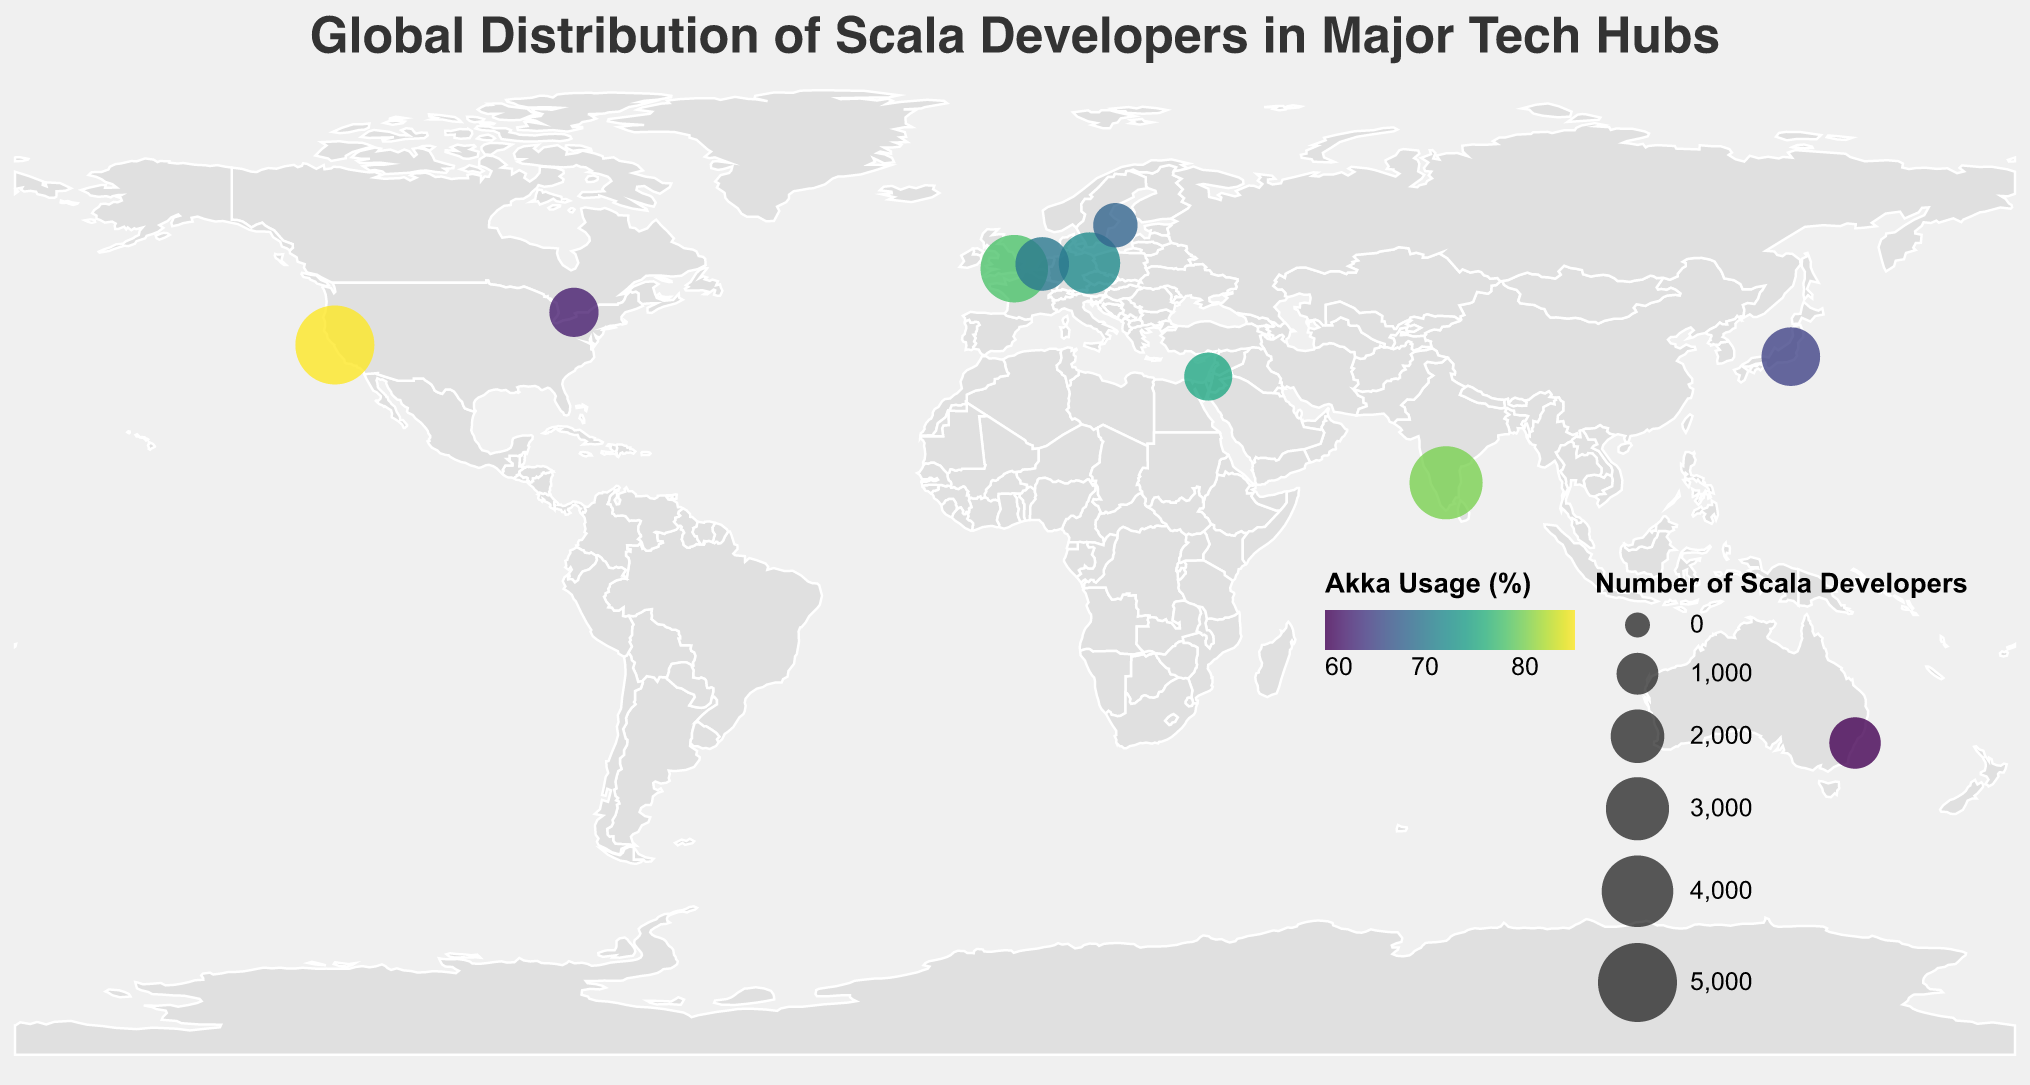What's the title of the figure? The title of the figure is displayed at the top and reads "Global Distribution of Scala Developers in Major Tech Hubs".
Answer: Global Distribution of Scala Developers in Major Tech Hubs Which city has the highest number of Scala developers? By looking at the size of the circles, the largest one represents San Francisco, which has 5000 Scala developers.
Answer: San Francisco What's the range of values for Akka usage represented by the color scale? The color legend indicates that the range of Akka usage is from a minimum of 60% to a maximum of 85%.
Answer: 60% to 85% Between London and Bangalore, which city has higher Akka usage and by how much? London has an Akka usage of 78%, and Bangalore has 80%, so Bangalore has 2% higher Akka usage.
Answer: Bangalore by 2% Which city has the smallest number of Scala developers, and what's its Akka usage percentage? The smallest circle represents Stockholm, which has 1200 Scala developers and an Akka usage of 68%.
Answer: Stockholm, 68% How many cities have an Akka usage percentage higher than 75%? Visually identify the cities where the color indicates Akka usage above 75%. There are three cities: San Francisco (85%), Bangalore (80%), and Tel Aviv (75%).
Answer: 3 cities What is the combined total number of Scala developers in Tokyo and Sydney? Tokyo has 2500 Scala developers, and Sydney has 1800, making the combined total 2500 + 1800 = 4300 developers.
Answer: 4300 What's the average number of Scala developers in European cities listed in the figure? Identify the European cities: London (3500), Berlin (2800), Amsterdam (2000), Stockholm (1200). Add the Scala developers: 3500 + 2800 + 2000 + 1200 = 9500. Divide by 4 cities: 9500 / 4 = 2375.
Answer: 2375 Which city in Asia has the highest Akka usage, and what is the percentage? The cities in Asia can be identified by their locations: Bangalore, Tokyo, Tel Aviv. Among these, Bangalore has the highest Akka usage of 80%.
Answer: Bangalore, 80% How do the numbers of Scala developers in Tel Aviv and Toronto compare? Tel Aviv has 1500 Scala developers, and Toronto has 1600. Toronto has 100 more Scala developers than Tel Aviv.
Answer: Toronto by 100 